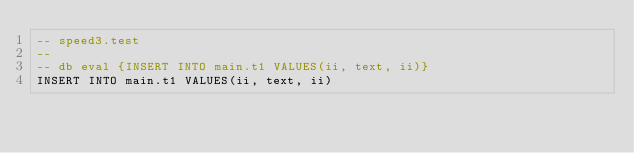Convert code to text. <code><loc_0><loc_0><loc_500><loc_500><_SQL_>-- speed3.test
-- 
-- db eval {INSERT INTO main.t1 VALUES(ii, text, ii)}
INSERT INTO main.t1 VALUES(ii, text, ii)
</code> 